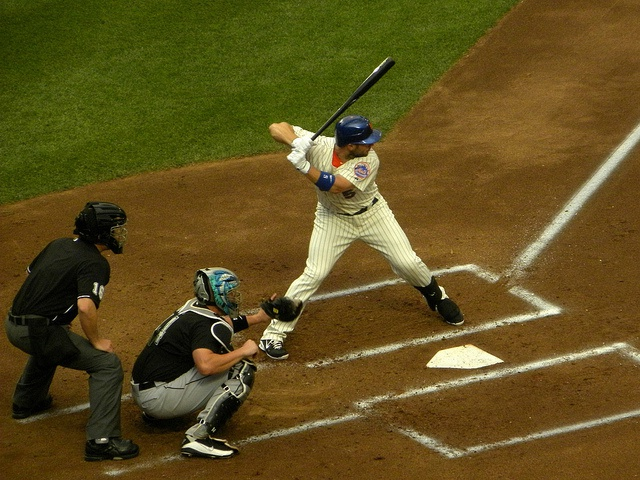Describe the objects in this image and their specific colors. I can see people in darkgreen, black, olive, and maroon tones, people in darkgreen, khaki, tan, black, and olive tones, people in darkgreen, black, and gray tones, baseball bat in darkgreen, black, and gray tones, and baseball glove in darkgreen, black, olive, and tan tones in this image. 